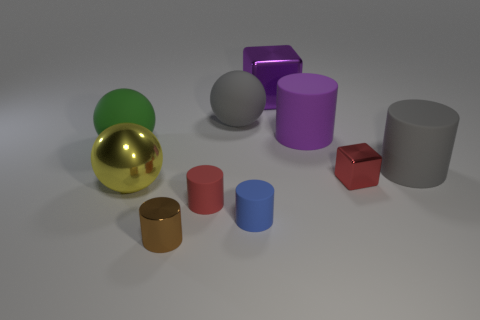Subtract all blue rubber cylinders. How many cylinders are left? 4 Subtract all green balls. How many balls are left? 2 Subtract all blocks. How many objects are left? 8 Subtract all purple blocks. How many gray cylinders are left? 1 Add 2 large gray things. How many large gray things are left? 4 Add 5 big purple rubber cylinders. How many big purple rubber cylinders exist? 6 Subtract 1 red cubes. How many objects are left? 9 Subtract 2 cubes. How many cubes are left? 0 Subtract all yellow cubes. Subtract all blue balls. How many cubes are left? 2 Subtract all tiny brown cylinders. Subtract all tiny brown shiny objects. How many objects are left? 8 